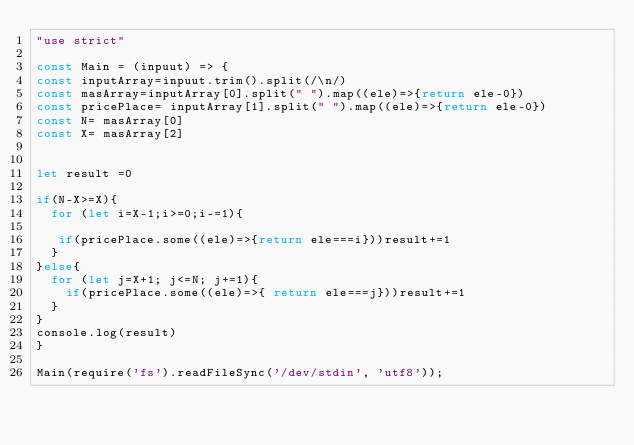Convert code to text. <code><loc_0><loc_0><loc_500><loc_500><_JavaScript_>"use strict"

const Main = (inpuut) => {
const inputArray=inpuut.trim().split(/\n/)
const masArray=inputArray[0].split(" ").map((ele)=>{return ele-0})
const pricePlace= inputArray[1].split(" ").map((ele)=>{return ele-0})
const N= masArray[0]
const X= masArray[2] 


let result =0

if(N-X>=X){
  for (let i=X-1;i>=0;i-=1){
   
   if(pricePlace.some((ele)=>{return ele===i}))result+=1
  }
}else{
  for (let j=X+1; j<=N; j+=1){
    if(pricePlace.some((ele)=>{ return ele===j}))result+=1
  }
}
console.log(result)
}

Main(require('fs').readFileSync('/dev/stdin', 'utf8'));</code> 